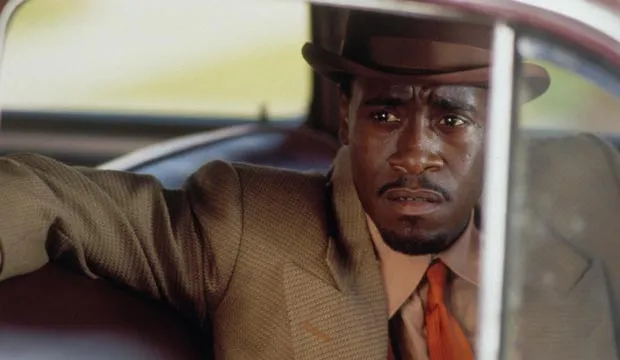Imagine this character's backstory. What might it be? This character could be an experienced detective working in a 1950s-era city. He has spent years solving complex cases, building a reputation for his sharp mind and relentless pursuit of justice. Raised in a rough neighborhood, he chose the path of the law to make a difference. His attire is a nod to his methodical and serious nature, embodying the classic image of a detective who trusts his instincts and values integrity above all. Throughout his career, he has seen it all – from petty crimes to major felonies – and he carries the burden of these experiences with a quiet resolve. What challenges might this detective face in his daily work? In his daily work, the detective faces numerous challenges: navigating the intricate web of criminal activities, dealing with uncooperative witnesses, and overcoming the bureaucratic red tape of the police department. Additionally, he often grapples with the moral ambiguities of his cases, making tough decisions that can weigh heavily on his conscience. Balancing his work with a personal life that may be strained by the demands of his job adds another layer of complexity to his existence. What could be a pivotal moment in his career? A pivotal moment in his career might occur when he faces a criminal mastermind whose cunning matches his own intellect. This adversary challenges him in ways that force him to re-evaluate his tactics and dig deeper into his own psyche. The pursuit is intense, filled with high-stakes encounters and near-defeats, culminating in a dramatic confrontation that tests his resolve and his dedication to justice. This case not only defines his career but also profoundly impacts his personal life and his view of the world. What happens after he retires? After retiring, the detective tries to find peace away from the relentless pursuit of criminals. However, the transition is not easy; he is haunted by the memories of unresolved cases and the faces of those he couldn't save. He takes up private investigations, helping those in need with his wealth of experience. Gradually, he finds solace in mentoring young detectives, passing on his wisdom and ensuring that the values he upheld continue to influence the next generation. His legacy lives on in the stories of his greatest cases, and he remains a respected figure in the community he once served. 